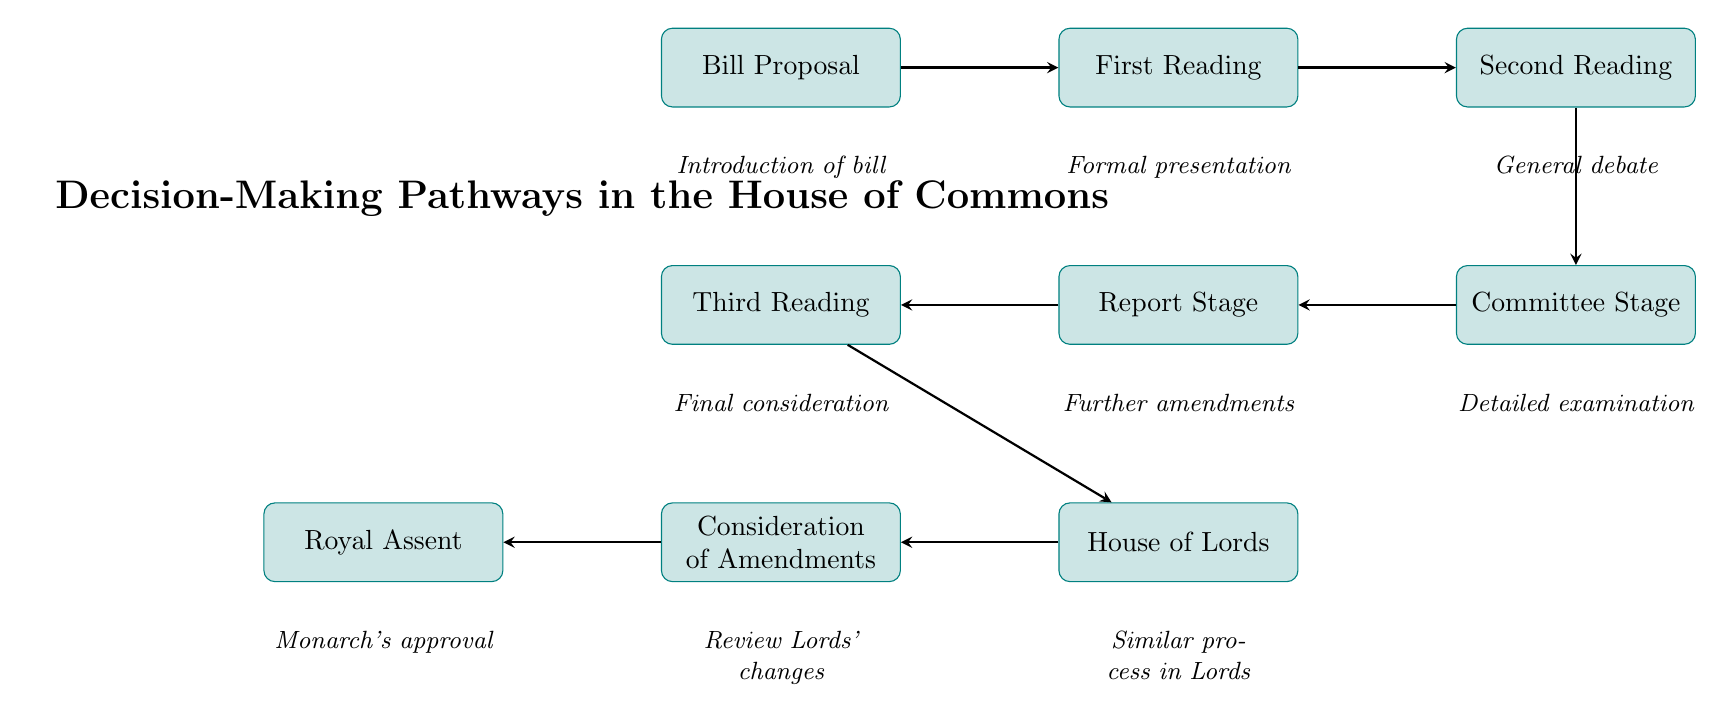What is the first step in the decision-making pathway? The first step in the pathway, as indicated in the diagram, is "Bill Proposal," which is where the process begins.
Answer: Bill Proposal How many stages does a bill go through in the House of Commons before it reaches the House of Lords? Counting the stages in the diagram, the stages are First Reading, Second Reading, Committee Stage, Report Stage, and Third Reading, which totals five stages.
Answer: 5 What stage follows the Committee Stage? According to the flow of the diagram, after the Committee Stage, the next stage is the Report Stage.
Answer: Report Stage Which stage involves a general debate on the main principles of the bill? The diagram specifies that the Second Reading is the stage where general debate on the main principles of the bill occurs.
Answer: Second Reading After the House of Commons, where does the bill go next? The diagram shows that once the bill concludes in the House of Commons, it is sent to the House of Lords.
Answer: House of Lords What occurs during the Consideration of Amendments stage? The diagram indicates that during this stage, the House of Commons reviews and considers any amendments made by the House of Lords.
Answer: Review Lords' changes What is the final step in the decision-making pathway? The final step illustrated in the diagram is Royal Assent, where the bill is sent to the monarch for approval to become an Act of Parliament.
Answer: Royal Assent What happens during the Third Reading? According to the diagram, during the Third Reading, there is a final consideration of the bill itself, focusing on its content rather than amendments.
Answer: Final consideration How does the process for the House of Lords compare to that of the House of Commons? The diagram notes that the process in the House of Lords involves going through a series of readings and stages similar to those in the House of Commons.
Answer: Similar process in Lords 